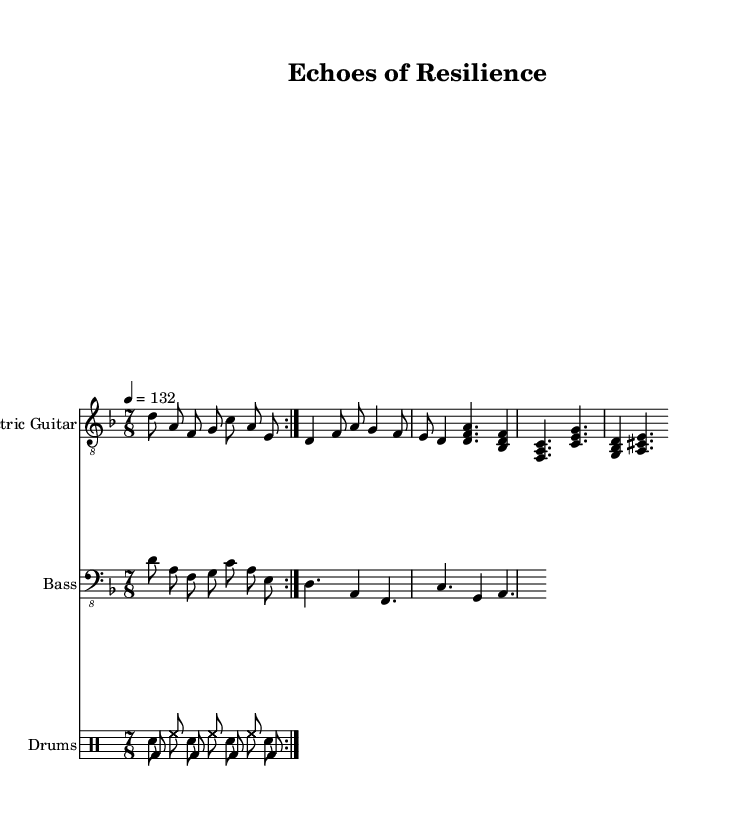What is the key signature of this music? The key signature is indicated by the presence of a flat symbol for B, thus showing there are two flats. This means the key is D minor, which contains the notes D, E, F, G, A, B♭, and C.
Answer: D minor What is the time signature of this music? The time signature is located at the beginning of the score and is noted as 7/8, indicating there are seven beats in a measure and the eighth note is the unit of measurement.
Answer: 7/8 What is the tempo marking of this music? The tempo marking is specified just above the staff and states "4 = 132," meaning there are 132 beats per minute, which refers specifically to the quarter note being the reference note.
Answer: 132 How many times is the main riff repeated? The main riff is marked with a "repeat volta" directive which indicates it should be played two times. The phrase preceding the repeat will occur again, comprising the first part of the song structure.
Answer: 2 What dynamics are indicated for the electric guitar in the chorus melody? While dynamics are not depicted in the provided snippet, one can infer typical metal dynamics during choruses would be stronger than verses. Yet, without explicit markings in the sheet, this remains speculative.
Answer: Not specified What instrument plays the main riff along with the bass guitar? The sheet music shows a section where both the electric guitar and the bass guitar play the same accompanying riff together, making this a blended moment in the piece, a common technique in progressive metal.
Answer: Electric guitar How is the emotional theme represented in the music? The introspective lyrics likely reflect the family dynamics and personal growth theme through the music's complexity, incorporating changes in dynamics, tempo, and texture that embody these emotions, characteristic of progressive metal.
Answer: Progressive metal techniques 